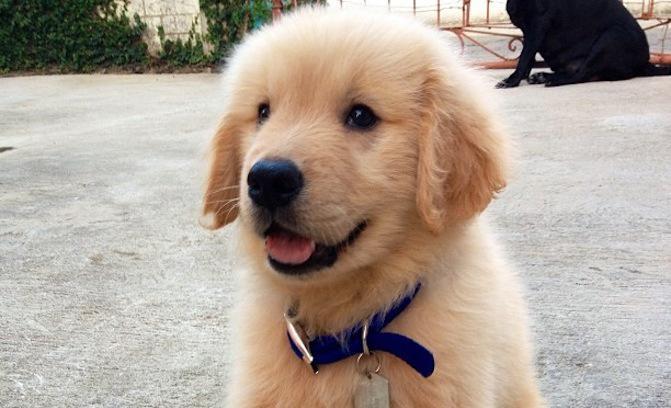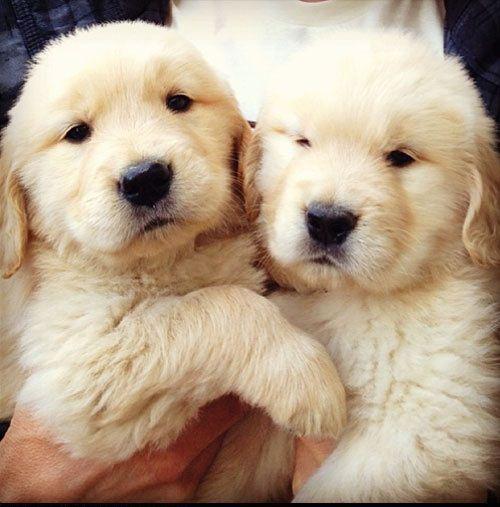The first image is the image on the left, the second image is the image on the right. Assess this claim about the two images: "In one of the images there are at least two puppies right next to each other.". Correct or not? Answer yes or no. Yes. The first image is the image on the left, the second image is the image on the right. For the images shown, is this caption "There are at least three dogs." true? Answer yes or no. Yes. 